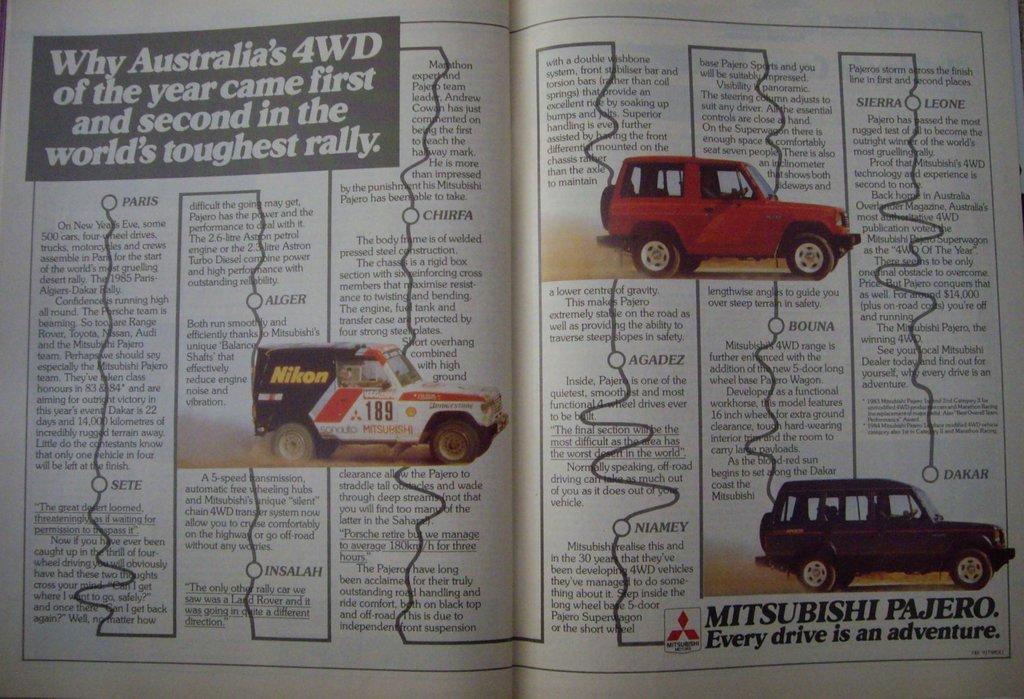Describe this image in one or two sentences. In this image we can see a book open. On the papers of the book there is some text, vehicles and a logo. 